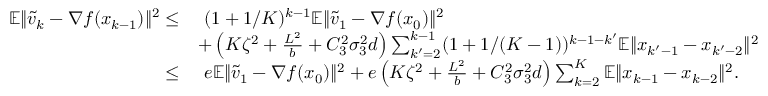<formula> <loc_0><loc_0><loc_500><loc_500>\begin{array} { r l } { \mathbb { E } \| \widetilde { v } _ { k } - \nabla f ( x _ { k - 1 } ) \| ^ { 2 } \leq } & { \ ( 1 + 1 / K ) ^ { k - 1 } \mathbb { E } \| \widetilde { v } _ { 1 } - \nabla f ( x _ { 0 } ) \| ^ { 2 } } \\ & { + \left ( K \zeta ^ { 2 } + \frac { L ^ { 2 } } { b } + C _ { 3 } ^ { 2 } \sigma _ { 3 } ^ { 2 } d \right ) \sum _ { k ^ { \prime } = 2 } ^ { k - 1 } ( 1 + 1 / ( K - 1 ) ) ^ { k - 1 - k ^ { \prime } } \mathbb { E } \| x _ { k ^ { \prime } - 1 } - x _ { k ^ { \prime } - 2 } \| ^ { 2 } } \\ { \leq } & { \ e \mathbb { E } \| \widetilde { v } _ { 1 } - \nabla f ( x _ { 0 } ) \| ^ { 2 } + e \left ( K \zeta ^ { 2 } + \frac { L ^ { 2 } } { b } + C _ { 3 } ^ { 2 } \sigma _ { 3 } ^ { 2 } d \right ) \sum _ { k = 2 } ^ { K } \mathbb { E } \| x _ { k - 1 } - x _ { k - 2 } \| ^ { 2 } . } \end{array}</formula> 